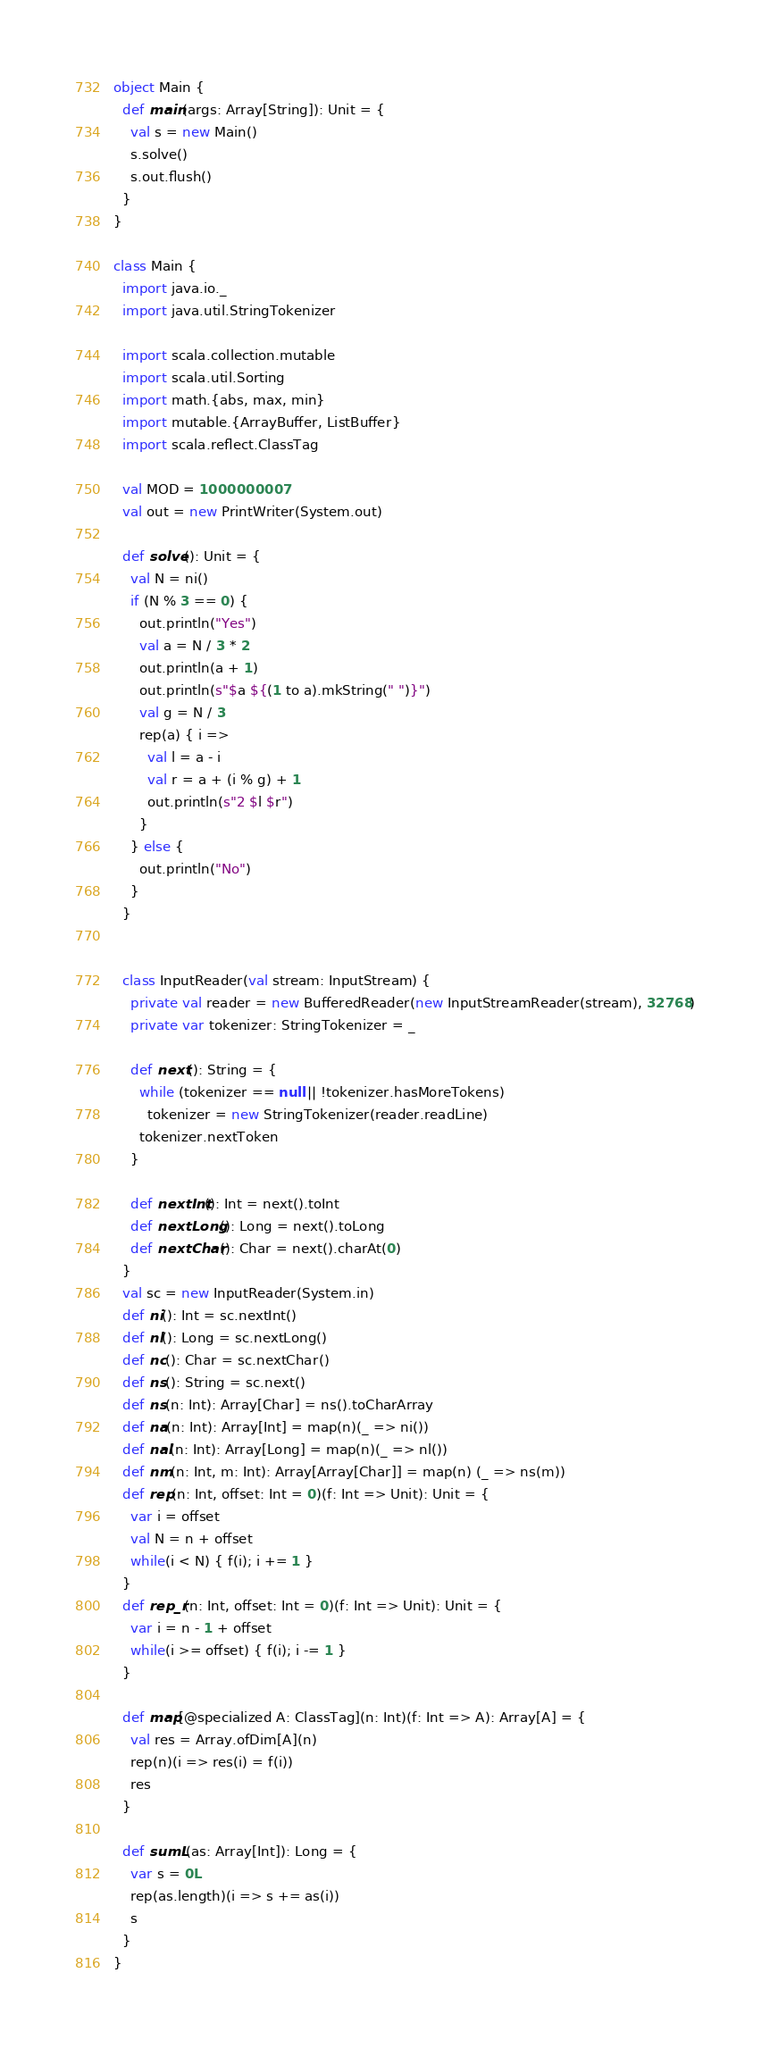Convert code to text. <code><loc_0><loc_0><loc_500><loc_500><_Scala_>object Main {
  def main(args: Array[String]): Unit = {
    val s = new Main()
    s.solve()
    s.out.flush()
  }
}

class Main {
  import java.io._
  import java.util.StringTokenizer

  import scala.collection.mutable
  import scala.util.Sorting
  import math.{abs, max, min}
  import mutable.{ArrayBuffer, ListBuffer}
  import scala.reflect.ClassTag

  val MOD = 1000000007
  val out = new PrintWriter(System.out)

  def solve(): Unit = {
    val N = ni()
    if (N % 3 == 0) {
      out.println("Yes")
      val a = N / 3 * 2
      out.println(a + 1)
      out.println(s"$a ${(1 to a).mkString(" ")}")
      val g = N / 3
      rep(a) { i =>
        val l = a - i
        val r = a + (i % g) + 1
        out.println(s"2 $l $r")
      }
    } else {
      out.println("No")
    }
  }


  class InputReader(val stream: InputStream) {
    private val reader = new BufferedReader(new InputStreamReader(stream), 32768)
    private var tokenizer: StringTokenizer = _

    def next(): String = {
      while (tokenizer == null || !tokenizer.hasMoreTokens)
        tokenizer = new StringTokenizer(reader.readLine)
      tokenizer.nextToken
    }

    def nextInt(): Int = next().toInt
    def nextLong(): Long = next().toLong
    def nextChar(): Char = next().charAt(0)
  }
  val sc = new InputReader(System.in)
  def ni(): Int = sc.nextInt()
  def nl(): Long = sc.nextLong()
  def nc(): Char = sc.nextChar()
  def ns(): String = sc.next()
  def ns(n: Int): Array[Char] = ns().toCharArray
  def na(n: Int): Array[Int] = map(n)(_ => ni())
  def nal(n: Int): Array[Long] = map(n)(_ => nl())
  def nm(n: Int, m: Int): Array[Array[Char]] = map(n) (_ => ns(m))
  def rep(n: Int, offset: Int = 0)(f: Int => Unit): Unit = {
    var i = offset
    val N = n + offset
    while(i < N) { f(i); i += 1 }
  }
  def rep_r(n: Int, offset: Int = 0)(f: Int => Unit): Unit = {
    var i = n - 1 + offset
    while(i >= offset) { f(i); i -= 1 }
  }

  def map[@specialized A: ClassTag](n: Int)(f: Int => A): Array[A] = {
    val res = Array.ofDim[A](n)
    rep(n)(i => res(i) = f(i))
    res
  }

  def sumL(as: Array[Int]): Long = {
    var s = 0L
    rep(as.length)(i => s += as(i))
    s
  }
}</code> 